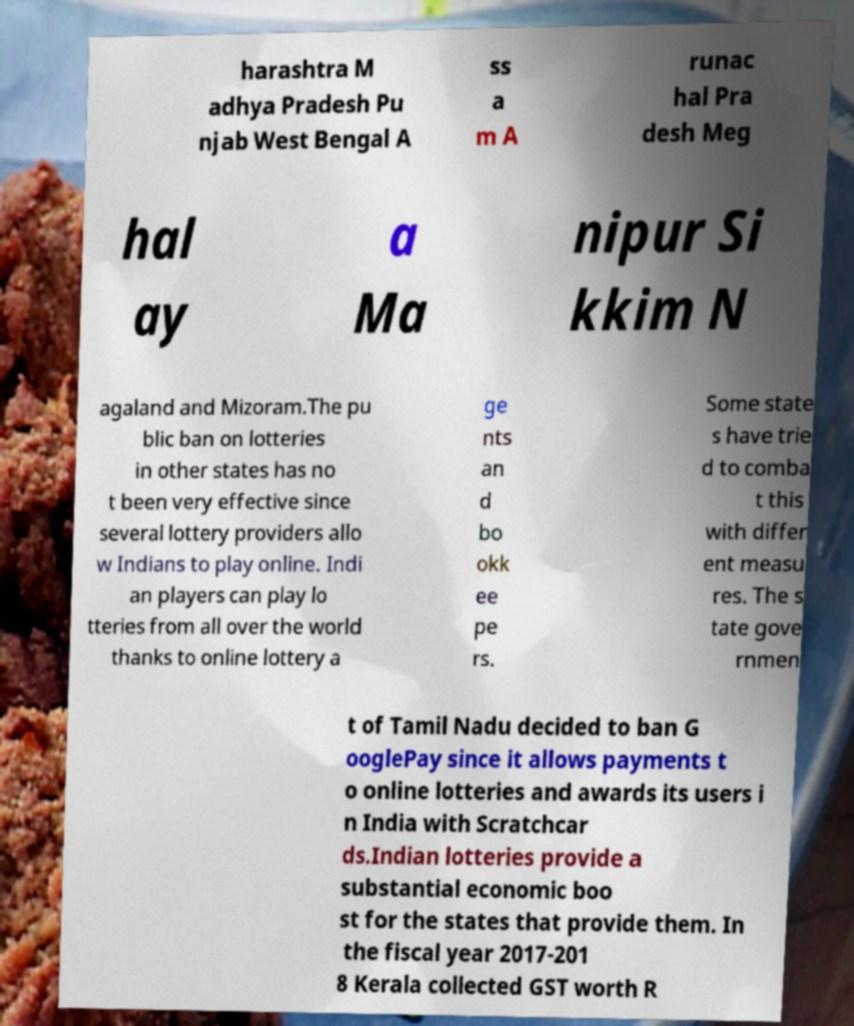Please read and relay the text visible in this image. What does it say? harashtra M adhya Pradesh Pu njab West Bengal A ss a m A runac hal Pra desh Meg hal ay a Ma nipur Si kkim N agaland and Mizoram.The pu blic ban on lotteries in other states has no t been very effective since several lottery providers allo w Indians to play online. Indi an players can play lo tteries from all over the world thanks to online lottery a ge nts an d bo okk ee pe rs. Some state s have trie d to comba t this with differ ent measu res. The s tate gove rnmen t of Tamil Nadu decided to ban G ooglePay since it allows payments t o online lotteries and awards its users i n India with Scratchcar ds.Indian lotteries provide a substantial economic boo st for the states that provide them. In the fiscal year 2017-201 8 Kerala collected GST worth R 